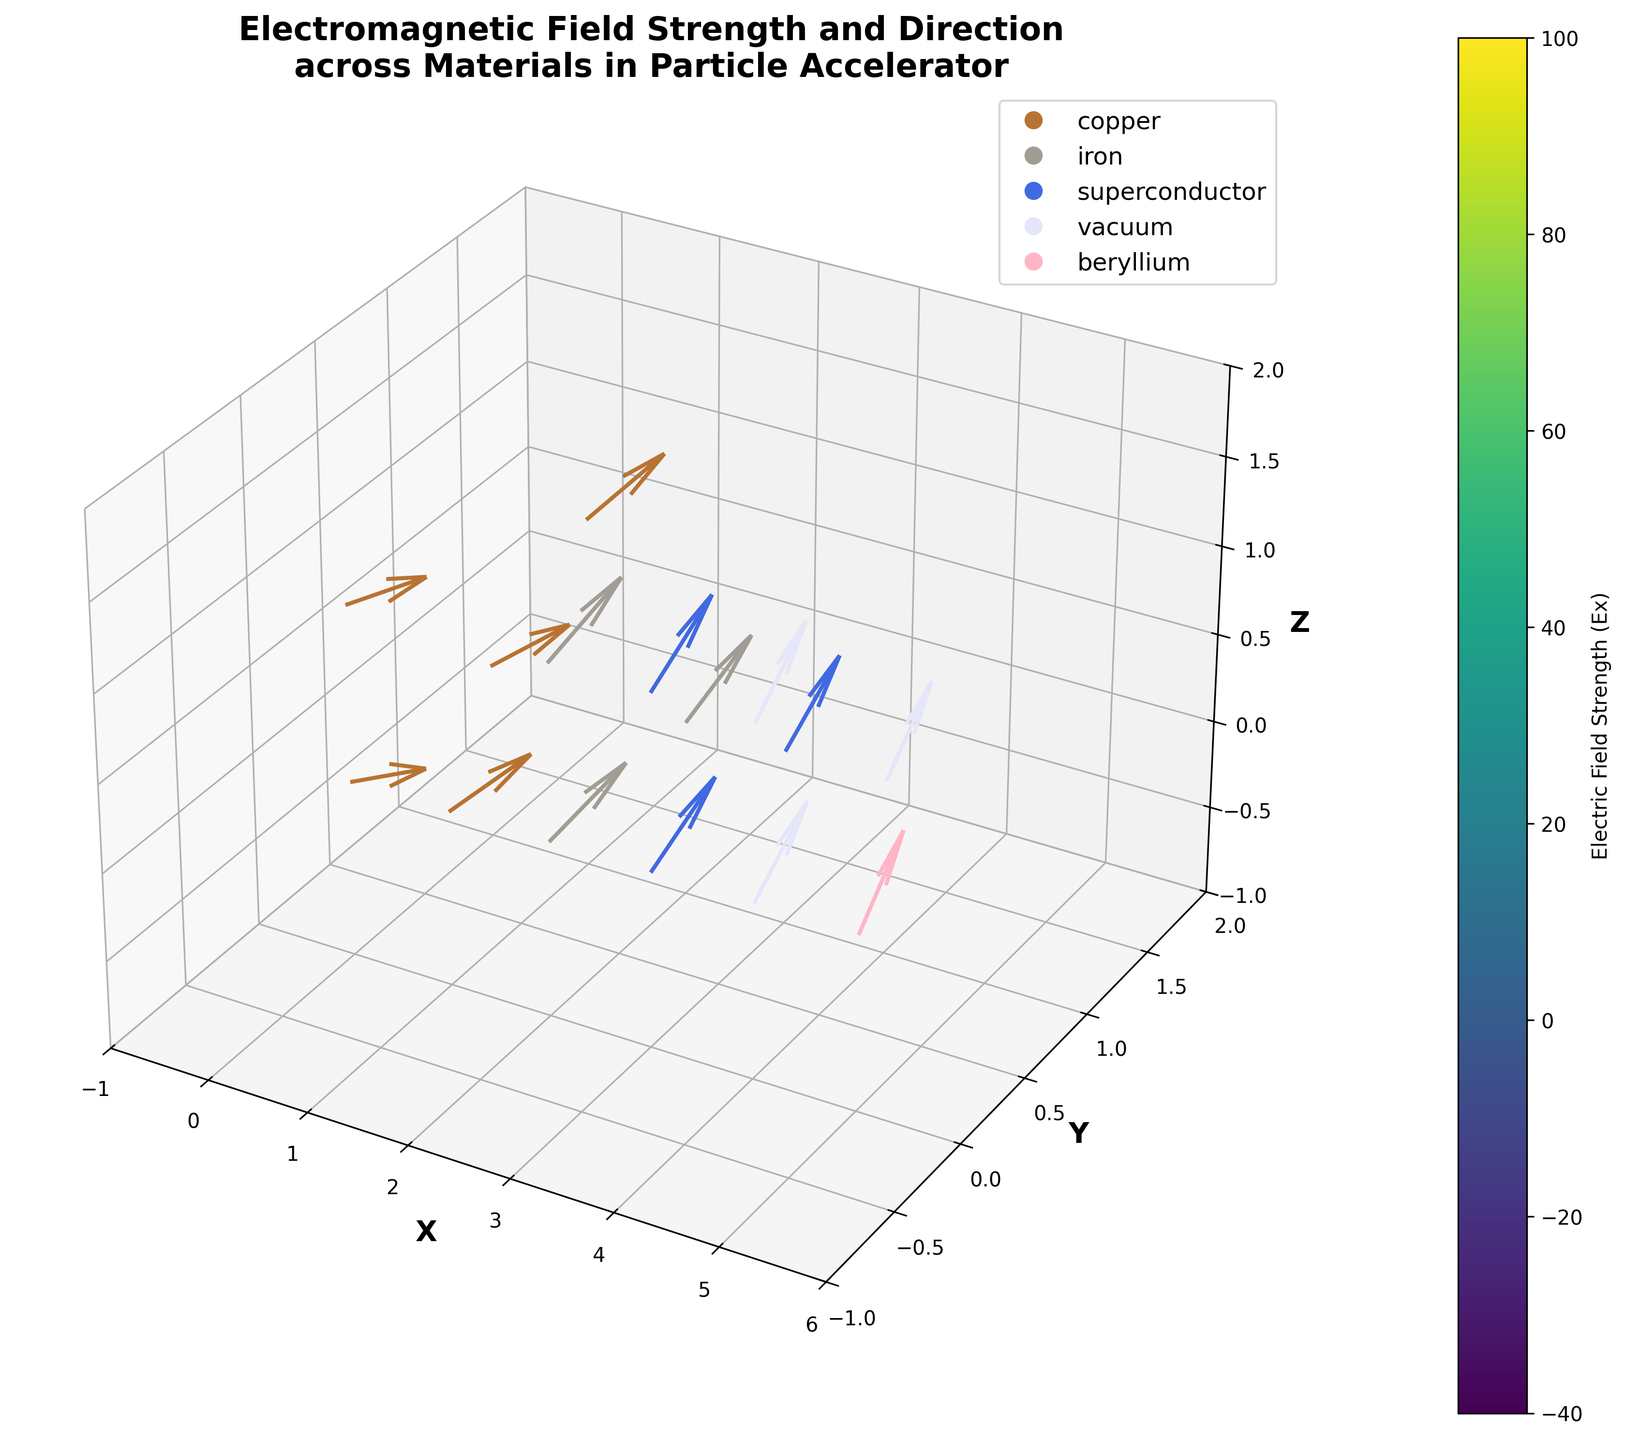How many unique materials are displayed in the plot? To determine the number of unique materials, look at the legend in the figure. Each unique color in the legend represents a different material. Count the number of different items listed in the legend.
Answer: 5 What is the title of the plot? The title of the plot is typically displayed at the top of the figure. Locate this text and read it.
Answer: Electromagnetic Field Strength and Direction across Materials in Particle Accelerator Which material has the strongest electric field strength in the X direction? By examining the color-coded arrows and the color bar, observe which material corresponds to the brightest color indicating the highest positive values in the X direction.
Answer: copper What are the X, Y, and Z coordinate ranges in the plot? Look at the axes' limits and labels to determine the minimum and maximum values of X, Y, and Z coordinates displayed in the plot.
Answer: X: -1 to 6, Y: -1 to 2, Z: -1 to 2 In which material does the Z component of the field vector remain zero? Check each vector's Z component across materials, or look for fields that remain in the XY plane (parallel to the XY plane) in the provided materials.
Answer: copper Which material shows the highest magnitude of the electric field components overall? Find the vectors with the largest magnitude by looking at the color intensities and arrow lengths, compared with the legend colors.
Answer: copper How does the field direction in iron compare to that in vacuum? Look at the orientation of the arrows for iron and vacuum, comparing their directions to see how they are aligned or differ in direction.
Answer: In iron, the fields mainly have higher Ey components compared to vacuum, where directions are more evenly distributed Which material exhibits a negative electric field strength component in the X direction? Identify the arrows pointing in the negative X direction and check the colors that correspond to them in the legend.
Answer: beryllium What can you infer about the electromagnetic field behavior in superconductors based on the plot? Observe the direction, length, and distribution of the vectors in the superconductor region and compare to others. Superconductor arrows are more uniformly distributed upward along the Y-axis, indicating a strong Ey component specifically.
Answer: Superconductors have a strong and uniformly positive Ey component Does the electric field have a significant Z component in any of the materials? Evaluate the length of arrows along the Z-axis and check for variations across different materials, especially by comparing the Ez values.
Answer: Yes, especially in iron with relatively high components along Z 